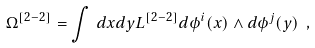<formula> <loc_0><loc_0><loc_500><loc_500>\Omega ^ { [ 2 - 2 ] } = \int \, d x d y { L } ^ { [ 2 - 2 ] } d \phi ^ { i } ( x ) \wedge d \phi ^ { j } ( y ) \ ,</formula> 